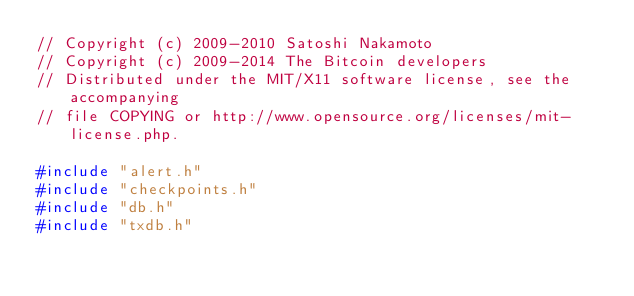<code> <loc_0><loc_0><loc_500><loc_500><_C++_>// Copyright (c) 2009-2010 Satoshi Nakamoto
// Copyright (c) 2009-2014 The Bitcoin developers
// Distributed under the MIT/X11 software license, see the accompanying
// file COPYING or http://www.opensource.org/licenses/mit-license.php.

#include "alert.h"
#include "checkpoints.h"
#include "db.h"
#include "txdb.h"</code> 